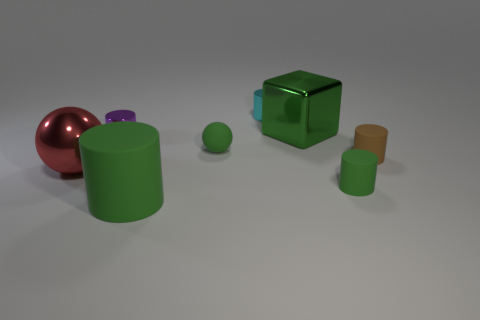How many shiny objects are green cylinders or tiny brown cylinders?
Provide a succinct answer. 0. The big shiny object that is the same color as the tiny matte sphere is what shape?
Ensure brevity in your answer.  Cube. There is a tiny rubber object in front of the large metallic sphere; is it the same color as the block?
Offer a terse response. Yes. There is a metallic thing that is behind the large green object to the right of the tiny cyan metal object; what shape is it?
Your answer should be compact. Cylinder. What number of objects are metal things that are in front of the brown matte thing or matte cylinders that are in front of the red object?
Provide a short and direct response. 3. The brown object that is the same material as the large green cylinder is what shape?
Offer a very short reply. Cylinder. Are there any other things that have the same color as the block?
Your response must be concise. Yes. Are there the same number of yellow metallic cylinders and objects?
Ensure brevity in your answer.  No. What material is the other object that is the same shape as the red thing?
Your response must be concise. Rubber. How many other things are the same size as the brown rubber cylinder?
Your answer should be compact. 4. 